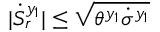<formula> <loc_0><loc_0><loc_500><loc_500>| \dot { S } _ { r } ^ { y _ { 1 } } | \leq \sqrt { \theta ^ { y _ { 1 } } \dot { \sigma } ^ { y _ { 1 } } }</formula> 